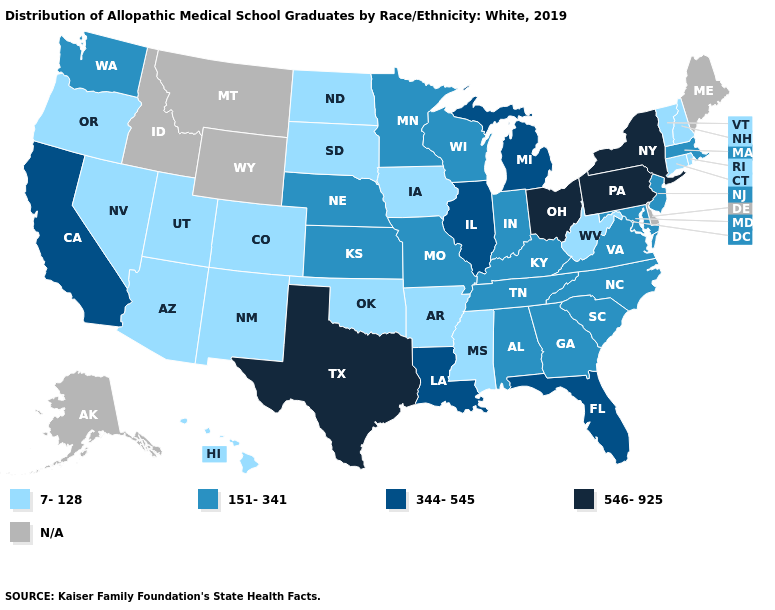Does the map have missing data?
Be succinct. Yes. Does Ohio have the highest value in the MidWest?
Quick response, please. Yes. Does Alabama have the highest value in the USA?
Keep it brief. No. How many symbols are there in the legend?
Keep it brief. 5. Name the states that have a value in the range 546-925?
Keep it brief. New York, Ohio, Pennsylvania, Texas. What is the highest value in the MidWest ?
Answer briefly. 546-925. What is the lowest value in states that border Tennessee?
Be succinct. 7-128. What is the value of Wisconsin?
Write a very short answer. 151-341. What is the value of California?
Quick response, please. 344-545. Which states have the lowest value in the South?
Write a very short answer. Arkansas, Mississippi, Oklahoma, West Virginia. Name the states that have a value in the range N/A?
Be succinct. Alaska, Delaware, Idaho, Maine, Montana, Wyoming. How many symbols are there in the legend?
Write a very short answer. 5. Does the map have missing data?
Short answer required. Yes. 